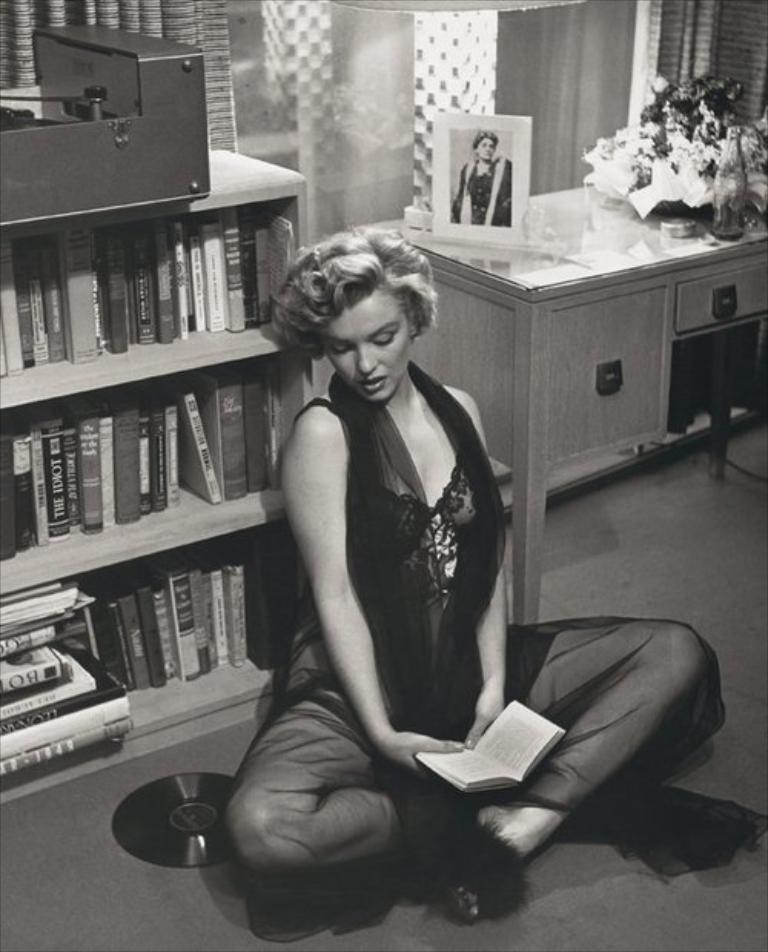Could you give a brief overview of what you see in this image? In the middle of the image a woman is sitting and holding a book. Behind her there is a bookshelf and table, on the table there is a frame and there are some flowers and bottle. 